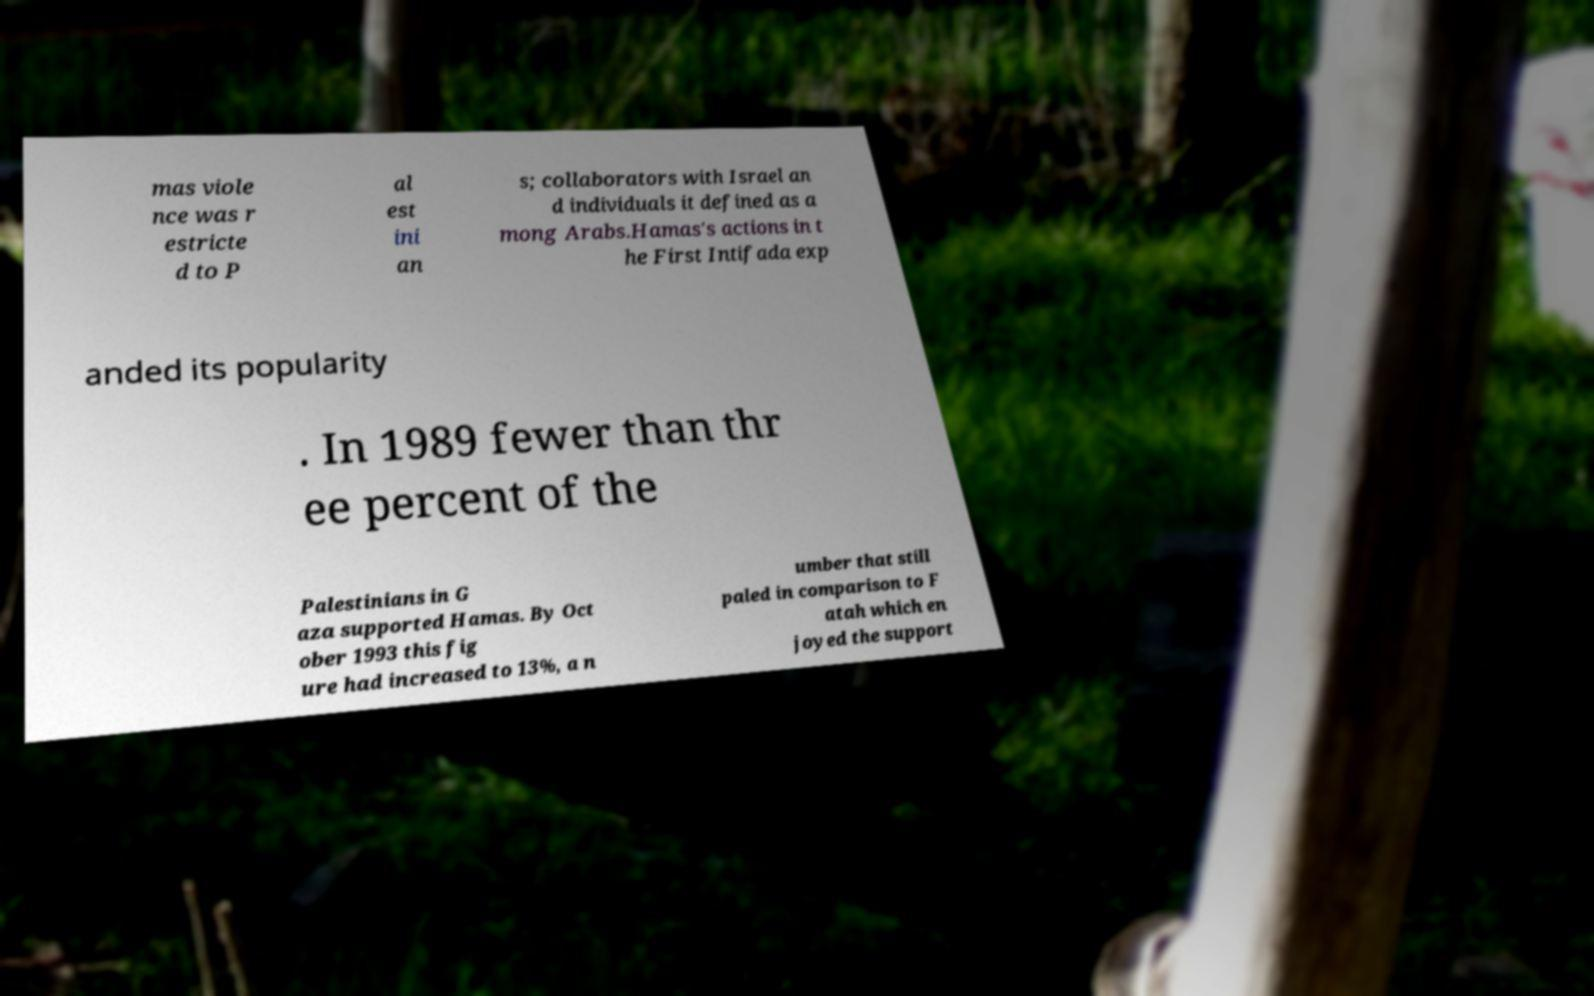For documentation purposes, I need the text within this image transcribed. Could you provide that? mas viole nce was r estricte d to P al est ini an s; collaborators with Israel an d individuals it defined as a mong Arabs.Hamas's actions in t he First Intifada exp anded its popularity . In 1989 fewer than thr ee percent of the Palestinians in G aza supported Hamas. By Oct ober 1993 this fig ure had increased to 13%, a n umber that still paled in comparison to F atah which en joyed the support 